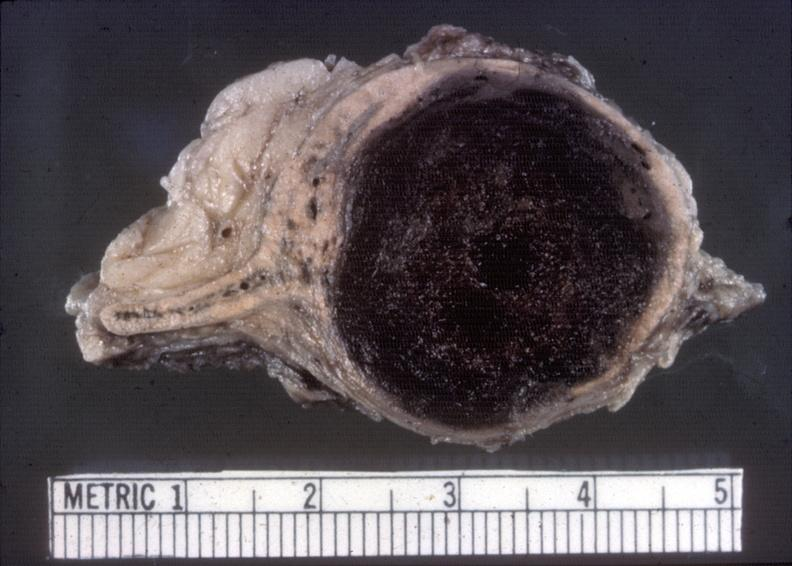s this image present?
Answer the question using a single word or phrase. No 